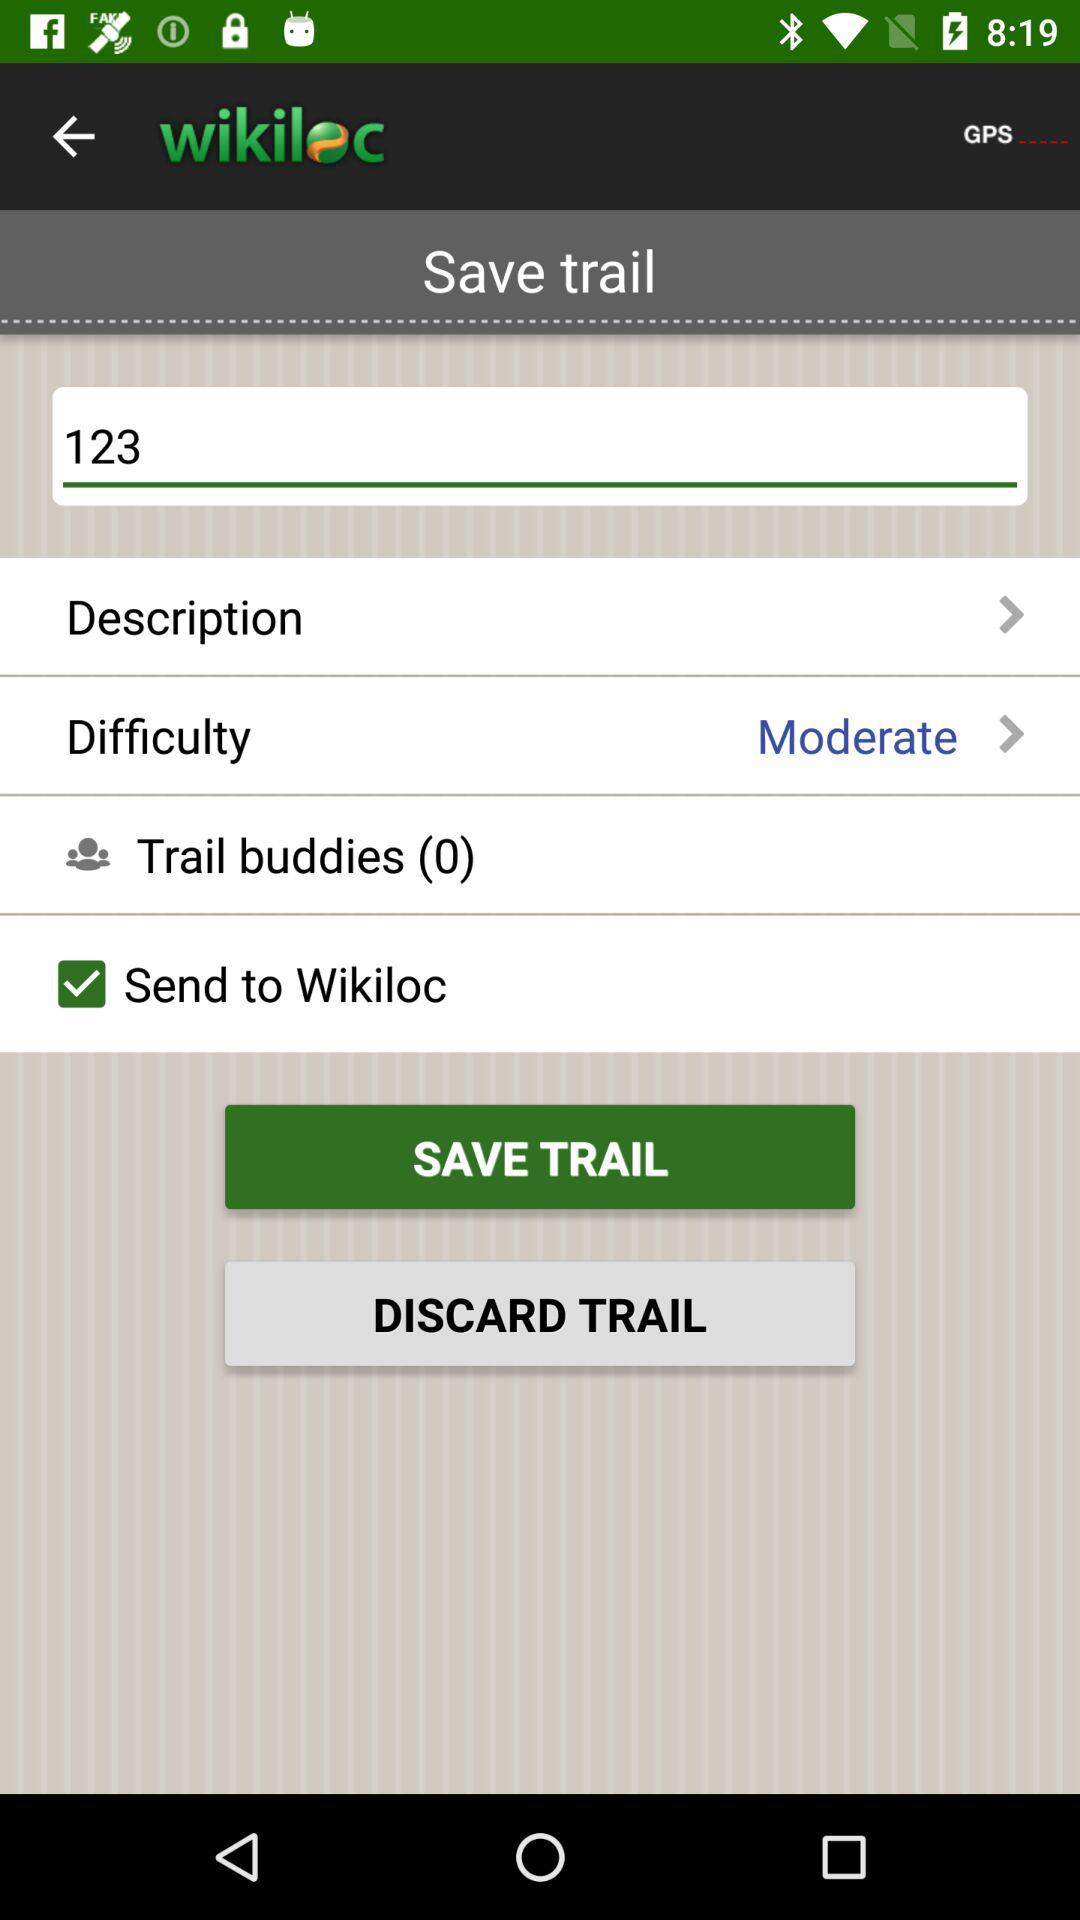How many trail buddies are there on the screen? There are 0 trail buddies on the screen. 